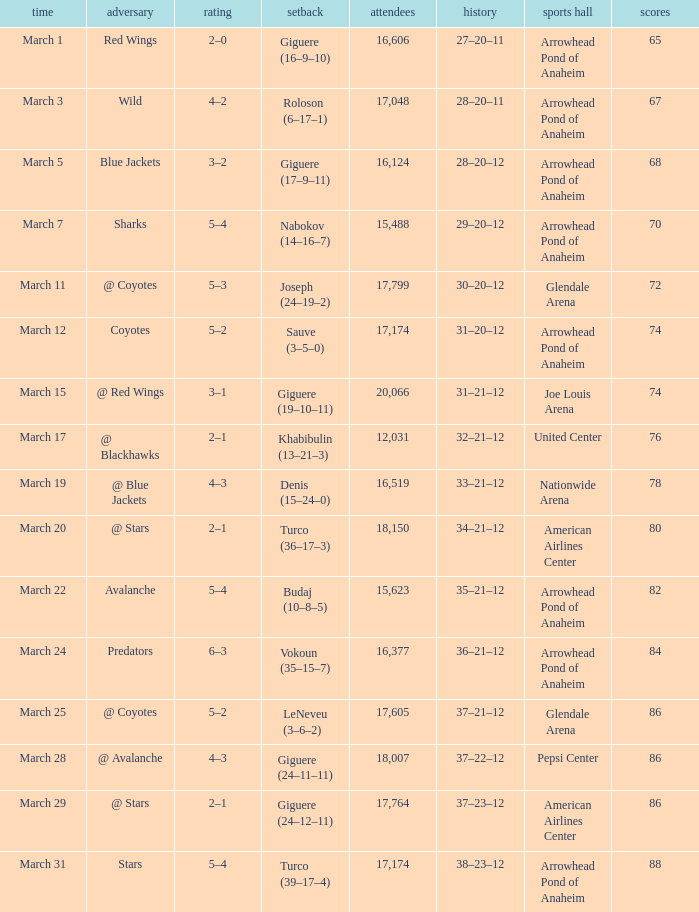What is the Loss of the game at Nationwide Arena with a Score of 4–3? Denis (15–24–0). 